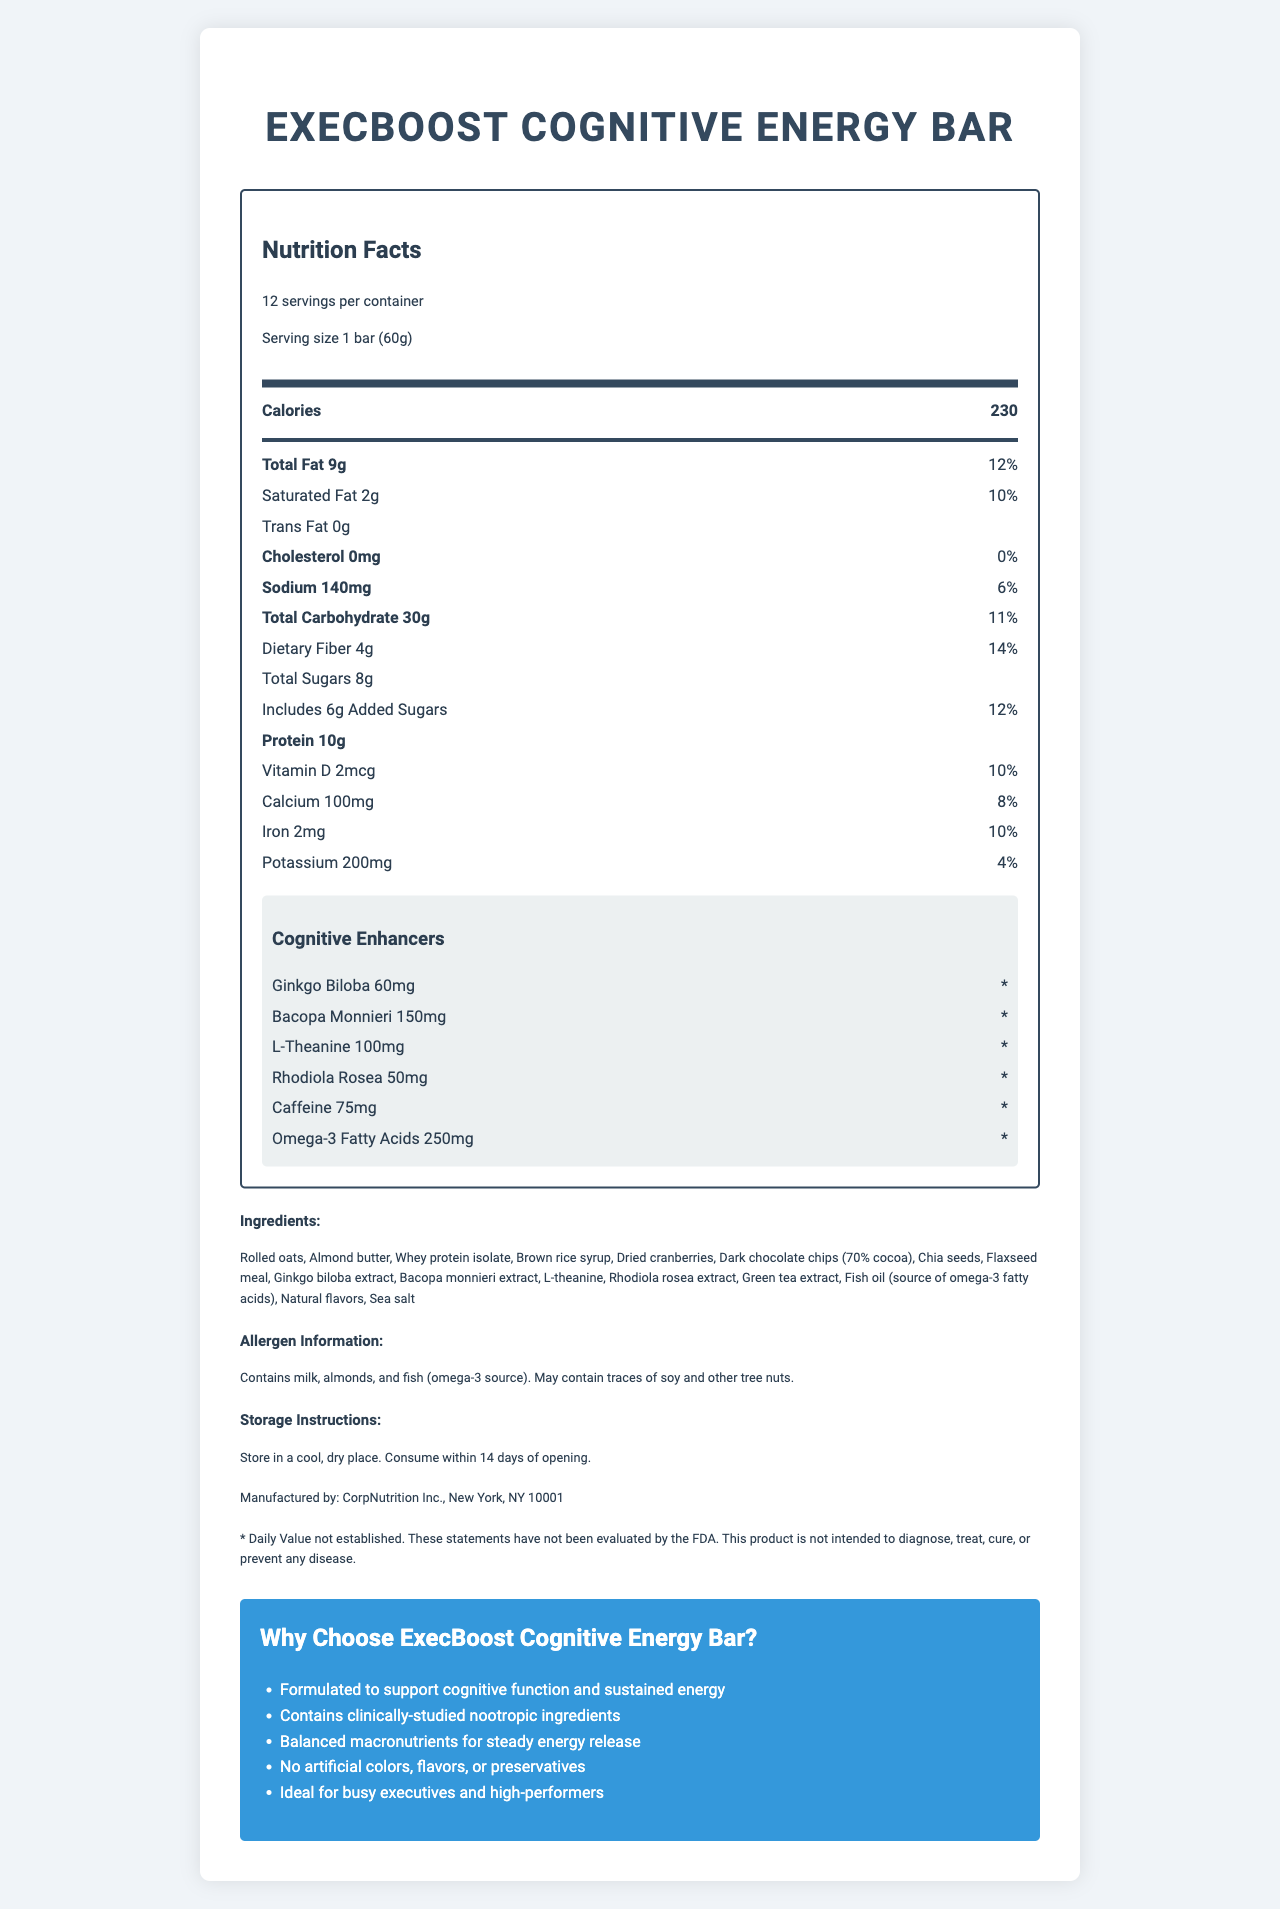what is the serving size for the ExecBoost Cognitive Energy Bar? The serving size is explicitly mentioned as "1 bar (60g)" in the serving information.
Answer: 1 bar (60g) how many calories are in one serving? The calories per serving are listed as 230 in the main nutrients section.
Answer: 230 how much protein does one bar contain? The protein content is listed in the main nutrients section as 10g.
Answer: 10g what is the amount of added sugars in one serving? The amount of added sugars is found under the sugars section, listed as "Includes 6g Added Sugars."
Answer: 6g does the energy bar contain any cholesterol? The cholesterol amount is listed as "0mg," indicating there is no cholesterol in the bar.
Answer: No (0mg) what are the cognitive enhancers included in the ExecBoost Cognitive Energy Bar? The cognitive enhancers are listed in a dedicated section and include Ginkgo Biloba (60mg), Bacopa Monnieri (150mg), L-Theanine (100mg), Rhodiola Rosea (50mg), and Caffeine (75mg).
Answer: Ginkgo Biloba, Bacopa Monnieri, L-Theanine, Rhodiola Rosea, and Caffeine how much omega-3 fatty acids does each bar contain? The amount of omega-3 fatty acids is listed as 250mg in the cognitive enhancers section.
Answer: 250mg which of the following is NOT an ingredient in the ExecBoost Cognitive Energy Bar? A. Flaxseed meal B. Sunflower seeds C. Rolled oats D. Dark chocolate chips Sunflower seeds are not listed in the ingredients section, whereas the other options are.
Answer: B. Sunflower seeds where is the bar manufactured? A. Los Angeles, CA B. New York, NY C. Chicago, IL D. Miami, FL The manufacturer is listed as "CorpNutrition Inc., New York, NY 10001" in the manufacturer section.
Answer: B. New York, NY does the product contain any allergens? The allergen information section states that the product contains milk, almonds, and fish (omega-3 source), and may contain traces of soy and other tree nuts.
Answer: Yes is there any trans fat in the energy bar? The trans fat content is listed as "0g" in the nutrient rows, indicating there is no trans fat.
Answer: No (0g) what should you do to properly store the energy bar? The storage instructions advise to store the bar in a cool, dry place and consume within 14 days of opening.
Answer: Store in a cool, dry place. Consume within 14 days of opening. summarize the main idea of the document. The document details various aspects of the ExecBoost Cognitive Energy Bar, such as serving size, calorie count, nutrient details, cognitive enhancers, allergen info, storage guidelines, manufacturer, and its marketing points tailored for corporate leaders.
Answer: The document is the Nutrition Facts Label for the ExecBoost Cognitive Energy Bar, highlighting its serving size, nutritional content, cognitive-enhancing ingredients, allergen information, storage instructions, manufacturer details, and marketing claims. how does the bar support cognitive function? The cognitive enhancers section lists ingredients specifically included to support cognitive function, reinforced by related marketing claims.
Answer: Contains clinically-studied nootropic ingredients like Ginkgo Biloba, Bacopa Monnieri, L-Theanine, Rhodiola Rosea, and Caffeine how many grams of dietary fiber are in one serving? The dietary fiber content is listed as 4g in the nutrient rows.
Answer: 4g what is the daily value percentage of vitamin D in one serving? The daily value percentage for vitamin D is listed as 10% in the nutrient rows.
Answer: 10% is the product intended to diagnose, treat, cure, or prevent any disease? The disclaimer specifies that the product is not intended to diagnose, treat, cure, or prevent any disease.
Answer: No does the document specify the exact effect of each cognitive enhancer? The document provides the names and amounts of cognitive enhancers but does not specify their exact effects. The answer to the question cannot be determined based on the visual information in the document.
Answer: No 